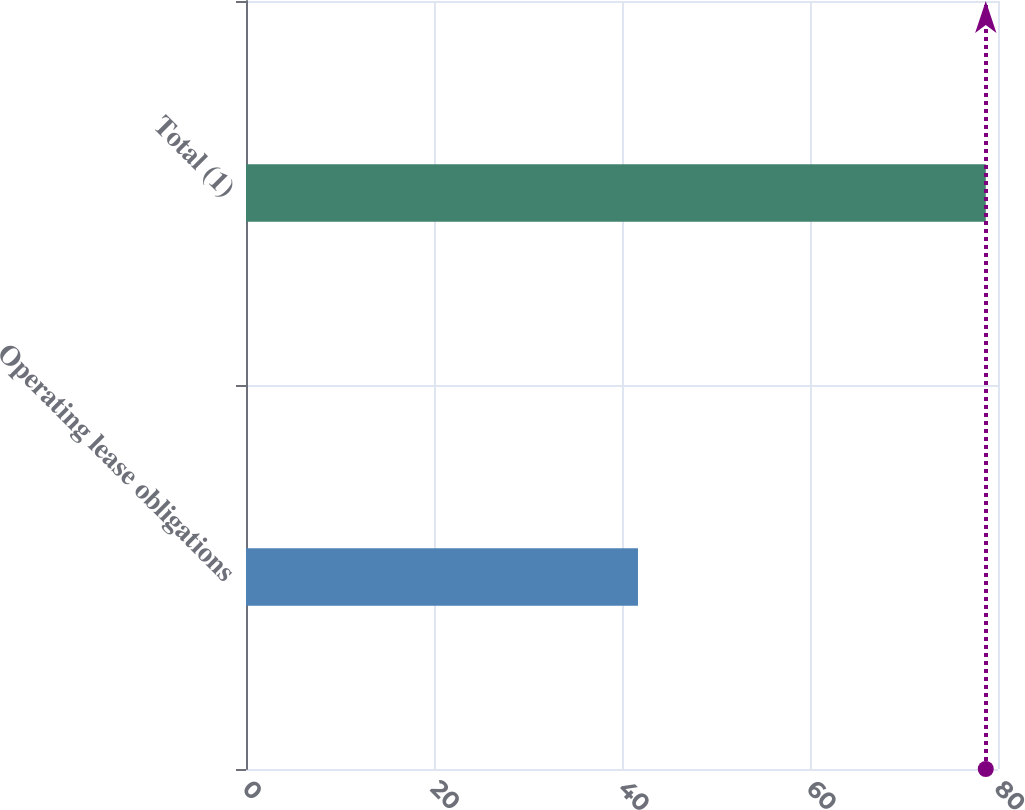Convert chart to OTSL. <chart><loc_0><loc_0><loc_500><loc_500><bar_chart><fcel>Operating lease obligations<fcel>Total (1)<nl><fcel>41.7<fcel>78.7<nl></chart> 